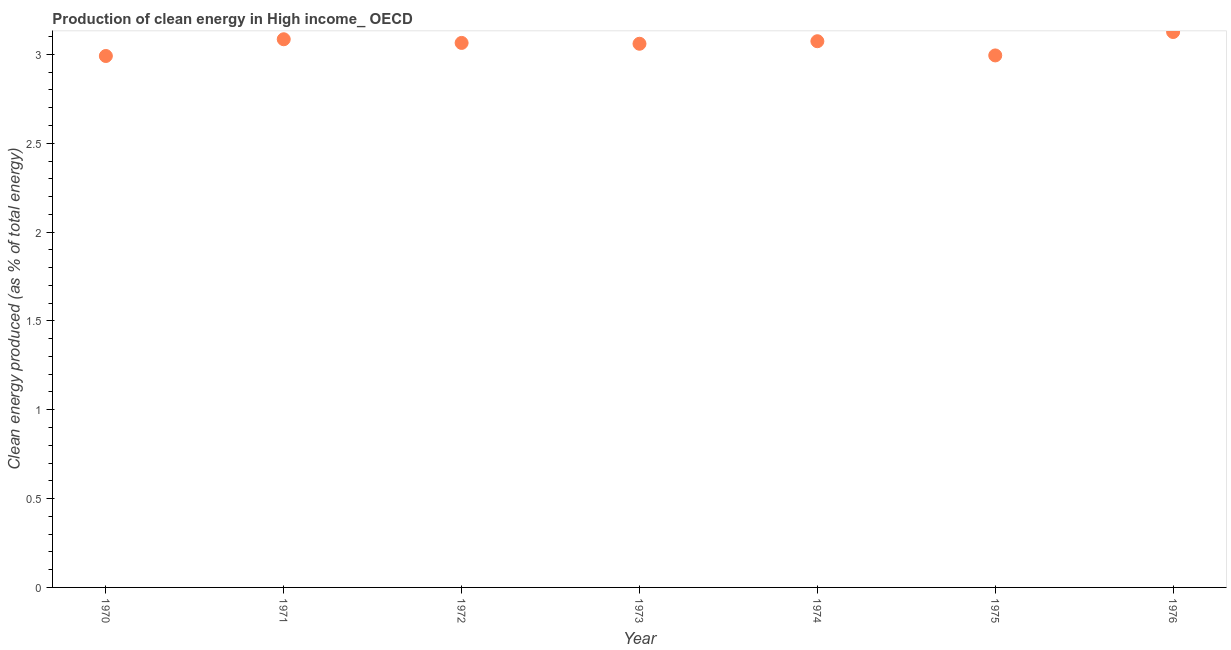What is the production of clean energy in 1975?
Your response must be concise. 2.99. Across all years, what is the maximum production of clean energy?
Offer a terse response. 3.13. Across all years, what is the minimum production of clean energy?
Your answer should be compact. 2.99. In which year was the production of clean energy maximum?
Your answer should be very brief. 1976. What is the sum of the production of clean energy?
Your answer should be compact. 21.4. What is the difference between the production of clean energy in 1974 and 1975?
Your response must be concise. 0.08. What is the average production of clean energy per year?
Make the answer very short. 3.06. What is the median production of clean energy?
Provide a succinct answer. 3.06. Do a majority of the years between 1970 and 1974 (inclusive) have production of clean energy greater than 0.2 %?
Offer a very short reply. Yes. What is the ratio of the production of clean energy in 1970 to that in 1974?
Keep it short and to the point. 0.97. What is the difference between the highest and the second highest production of clean energy?
Provide a succinct answer. 0.04. What is the difference between the highest and the lowest production of clean energy?
Keep it short and to the point. 0.13. How many dotlines are there?
Provide a succinct answer. 1. How many years are there in the graph?
Offer a terse response. 7. What is the difference between two consecutive major ticks on the Y-axis?
Provide a succinct answer. 0.5. Does the graph contain any zero values?
Give a very brief answer. No. Does the graph contain grids?
Offer a terse response. No. What is the title of the graph?
Offer a terse response. Production of clean energy in High income_ OECD. What is the label or title of the Y-axis?
Your answer should be very brief. Clean energy produced (as % of total energy). What is the Clean energy produced (as % of total energy) in 1970?
Ensure brevity in your answer.  2.99. What is the Clean energy produced (as % of total energy) in 1971?
Provide a succinct answer. 3.09. What is the Clean energy produced (as % of total energy) in 1972?
Make the answer very short. 3.06. What is the Clean energy produced (as % of total energy) in 1973?
Make the answer very short. 3.06. What is the Clean energy produced (as % of total energy) in 1974?
Give a very brief answer. 3.07. What is the Clean energy produced (as % of total energy) in 1975?
Your answer should be compact. 2.99. What is the Clean energy produced (as % of total energy) in 1976?
Give a very brief answer. 3.13. What is the difference between the Clean energy produced (as % of total energy) in 1970 and 1971?
Ensure brevity in your answer.  -0.09. What is the difference between the Clean energy produced (as % of total energy) in 1970 and 1972?
Ensure brevity in your answer.  -0.07. What is the difference between the Clean energy produced (as % of total energy) in 1970 and 1973?
Provide a succinct answer. -0.07. What is the difference between the Clean energy produced (as % of total energy) in 1970 and 1974?
Your answer should be compact. -0.08. What is the difference between the Clean energy produced (as % of total energy) in 1970 and 1975?
Ensure brevity in your answer.  -0. What is the difference between the Clean energy produced (as % of total energy) in 1970 and 1976?
Give a very brief answer. -0.13. What is the difference between the Clean energy produced (as % of total energy) in 1971 and 1972?
Keep it short and to the point. 0.02. What is the difference between the Clean energy produced (as % of total energy) in 1971 and 1973?
Ensure brevity in your answer.  0.03. What is the difference between the Clean energy produced (as % of total energy) in 1971 and 1974?
Make the answer very short. 0.01. What is the difference between the Clean energy produced (as % of total energy) in 1971 and 1975?
Your response must be concise. 0.09. What is the difference between the Clean energy produced (as % of total energy) in 1971 and 1976?
Your answer should be compact. -0.04. What is the difference between the Clean energy produced (as % of total energy) in 1972 and 1973?
Your answer should be very brief. 0. What is the difference between the Clean energy produced (as % of total energy) in 1972 and 1974?
Make the answer very short. -0.01. What is the difference between the Clean energy produced (as % of total energy) in 1972 and 1975?
Your answer should be very brief. 0.07. What is the difference between the Clean energy produced (as % of total energy) in 1972 and 1976?
Ensure brevity in your answer.  -0.06. What is the difference between the Clean energy produced (as % of total energy) in 1973 and 1974?
Provide a short and direct response. -0.01. What is the difference between the Clean energy produced (as % of total energy) in 1973 and 1975?
Keep it short and to the point. 0.07. What is the difference between the Clean energy produced (as % of total energy) in 1973 and 1976?
Keep it short and to the point. -0.07. What is the difference between the Clean energy produced (as % of total energy) in 1974 and 1975?
Keep it short and to the point. 0.08. What is the difference between the Clean energy produced (as % of total energy) in 1974 and 1976?
Offer a very short reply. -0.05. What is the difference between the Clean energy produced (as % of total energy) in 1975 and 1976?
Your answer should be compact. -0.13. What is the ratio of the Clean energy produced (as % of total energy) in 1970 to that in 1971?
Ensure brevity in your answer.  0.97. What is the ratio of the Clean energy produced (as % of total energy) in 1970 to that in 1972?
Make the answer very short. 0.98. What is the ratio of the Clean energy produced (as % of total energy) in 1970 to that in 1976?
Offer a very short reply. 0.96. What is the ratio of the Clean energy produced (as % of total energy) in 1971 to that in 1972?
Provide a succinct answer. 1.01. What is the ratio of the Clean energy produced (as % of total energy) in 1971 to that in 1973?
Provide a succinct answer. 1.01. What is the ratio of the Clean energy produced (as % of total energy) in 1971 to that in 1974?
Provide a short and direct response. 1. What is the ratio of the Clean energy produced (as % of total energy) in 1972 to that in 1973?
Ensure brevity in your answer.  1. What is the ratio of the Clean energy produced (as % of total energy) in 1972 to that in 1974?
Your answer should be very brief. 1. What is the ratio of the Clean energy produced (as % of total energy) in 1972 to that in 1976?
Your answer should be very brief. 0.98. What is the ratio of the Clean energy produced (as % of total energy) in 1973 to that in 1975?
Your answer should be compact. 1.02. What is the ratio of the Clean energy produced (as % of total energy) in 1973 to that in 1976?
Offer a terse response. 0.98. What is the ratio of the Clean energy produced (as % of total energy) in 1974 to that in 1975?
Offer a terse response. 1.03. What is the ratio of the Clean energy produced (as % of total energy) in 1975 to that in 1976?
Offer a very short reply. 0.96. 